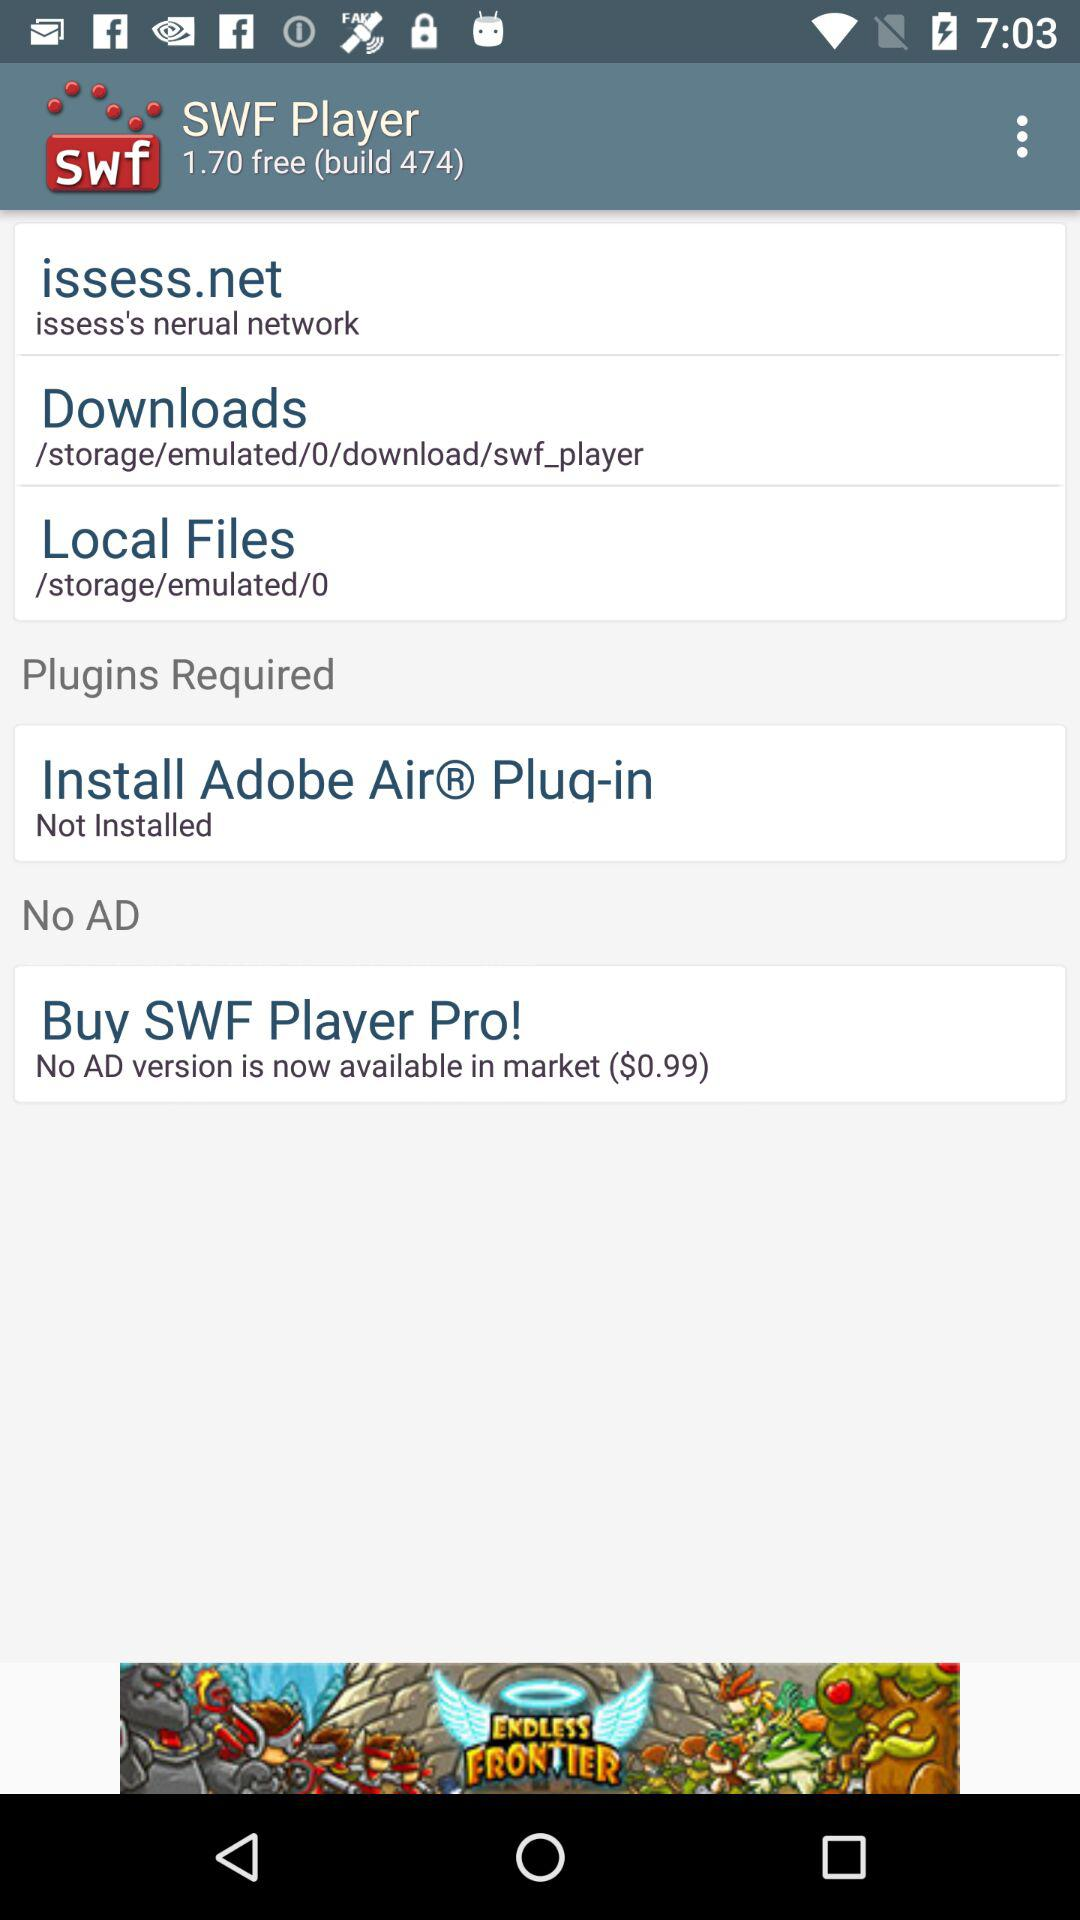What is the name of the application? The name of the application is "SWF Player". 